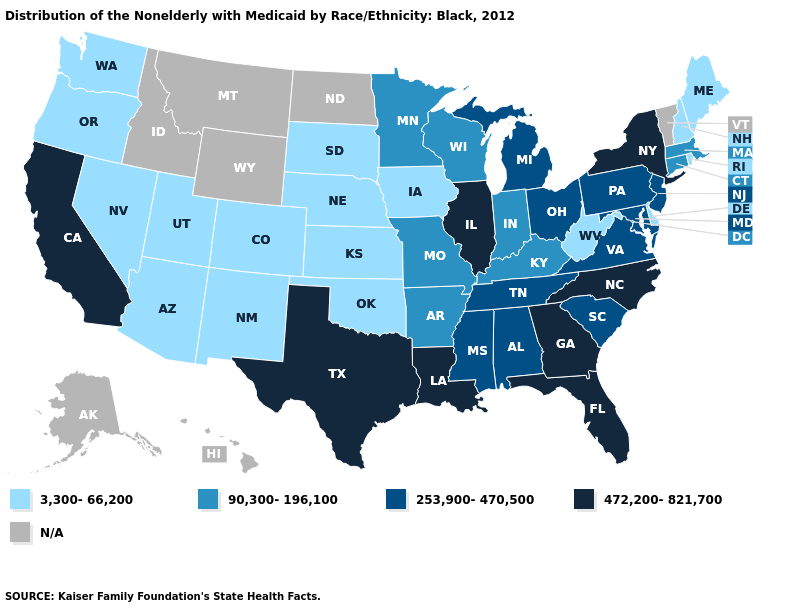What is the highest value in the West ?
Be succinct. 472,200-821,700. What is the lowest value in the West?
Short answer required. 3,300-66,200. Among the states that border Idaho , which have the lowest value?
Quick response, please. Nevada, Oregon, Utah, Washington. Name the states that have a value in the range 472,200-821,700?
Write a very short answer. California, Florida, Georgia, Illinois, Louisiana, New York, North Carolina, Texas. What is the value of Nevada?
Answer briefly. 3,300-66,200. What is the lowest value in states that border Washington?
Short answer required. 3,300-66,200. How many symbols are there in the legend?
Answer briefly. 5. How many symbols are there in the legend?
Concise answer only. 5. Which states have the lowest value in the Northeast?
Be succinct. Maine, New Hampshire, Rhode Island. Among the states that border Montana , which have the lowest value?
Answer briefly. South Dakota. What is the value of New Jersey?
Be succinct. 253,900-470,500. Does the first symbol in the legend represent the smallest category?
Answer briefly. Yes. What is the value of Delaware?
Answer briefly. 3,300-66,200. Name the states that have a value in the range 90,300-196,100?
Write a very short answer. Arkansas, Connecticut, Indiana, Kentucky, Massachusetts, Minnesota, Missouri, Wisconsin. Does Delaware have the lowest value in the South?
Write a very short answer. Yes. 